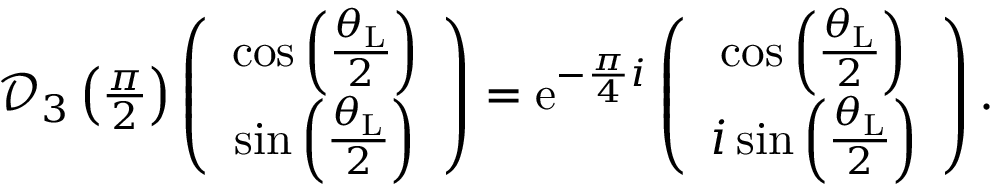<formula> <loc_0><loc_0><loc_500><loc_500>\begin{array} { r } { \mathcal { D } _ { 3 } \left ( \frac { \pi } { 2 } \right ) \left ( \begin{array} { c c } { \cos \left ( \frac { \theta _ { L } } { 2 } \right ) } \\ { \sin \left ( \frac { \theta _ { L } } { 2 } \right ) } \end{array} \right ) = e ^ { - \frac { \pi } { 4 } i } \left ( \begin{array} { c c } { \cos \left ( \frac { \theta _ { L } } { 2 } \right ) } \\ { i \sin \left ( \frac { \theta _ { L } } { 2 } \right ) } \end{array} \right ) . } \end{array}</formula> 